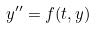Convert formula to latex. <formula><loc_0><loc_0><loc_500><loc_500>y ^ { \prime \prime } = f ( t , y )</formula> 